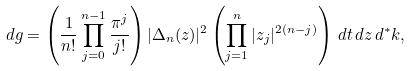<formula> <loc_0><loc_0><loc_500><loc_500>d g = \left ( \frac { 1 } { n ! } \prod _ { j = 0 } ^ { n - 1 } \frac { \pi ^ { j } } { j ! } \right ) | \Delta _ { n } ( z ) | ^ { 2 } \left ( \prod _ { j = 1 } ^ { n } | z _ { j } | ^ { 2 ( n - j ) } \right ) \, d t \, d z \, d ^ { * } k ,</formula> 